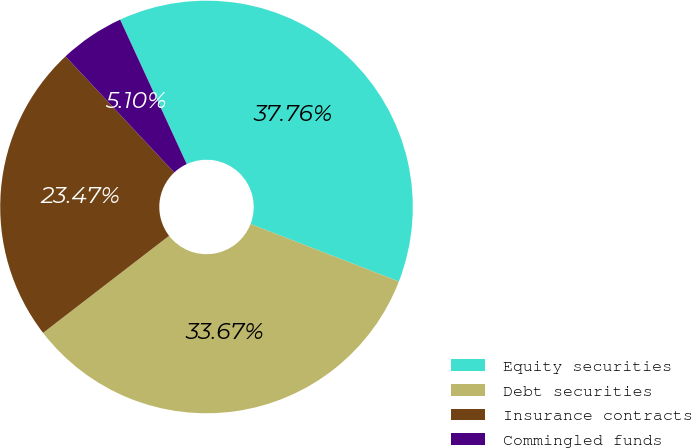Convert chart. <chart><loc_0><loc_0><loc_500><loc_500><pie_chart><fcel>Equity securities<fcel>Debt securities<fcel>Insurance contracts<fcel>Commingled funds<nl><fcel>37.76%<fcel>33.67%<fcel>23.47%<fcel>5.1%<nl></chart> 